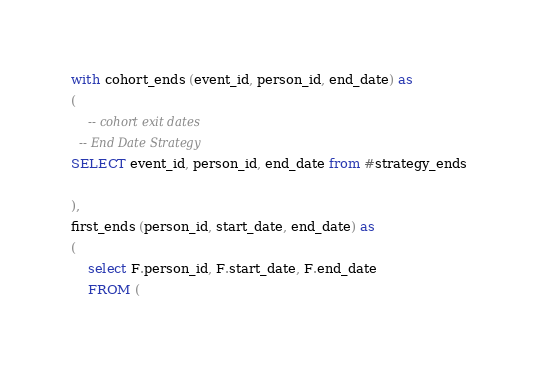<code> <loc_0><loc_0><loc_500><loc_500><_SQL_>with cohort_ends (event_id, person_id, end_date) as
(
	-- cohort exit dates
  -- End Date Strategy
SELECT event_id, person_id, end_date from #strategy_ends

),
first_ends (person_id, start_date, end_date) as
(
	select F.person_id, F.start_date, F.end_date
	FROM (</code> 